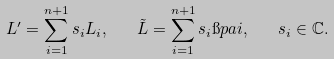Convert formula to latex. <formula><loc_0><loc_0><loc_500><loc_500>L ^ { \prime } = \sum _ { i = 1 } ^ { n + 1 } s _ { i } L _ { i } , \quad \tilde { L } = \sum _ { i = 1 } ^ { n + 1 } s _ { i } \i p a { i } , \quad s _ { i } \in \mathbb { C } .</formula> 